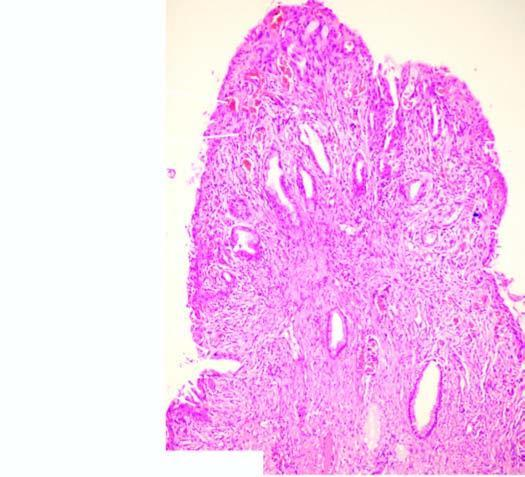s moebic liver abscess composed of dense fibrous tissue which shows nonspecific inflammation?
Answer the question using a single word or phrase. No 